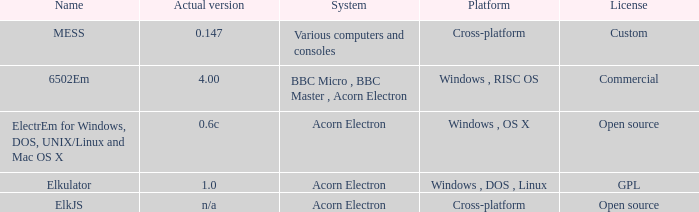What is the name of the platform used for various computers and consoles? Cross-platform. 